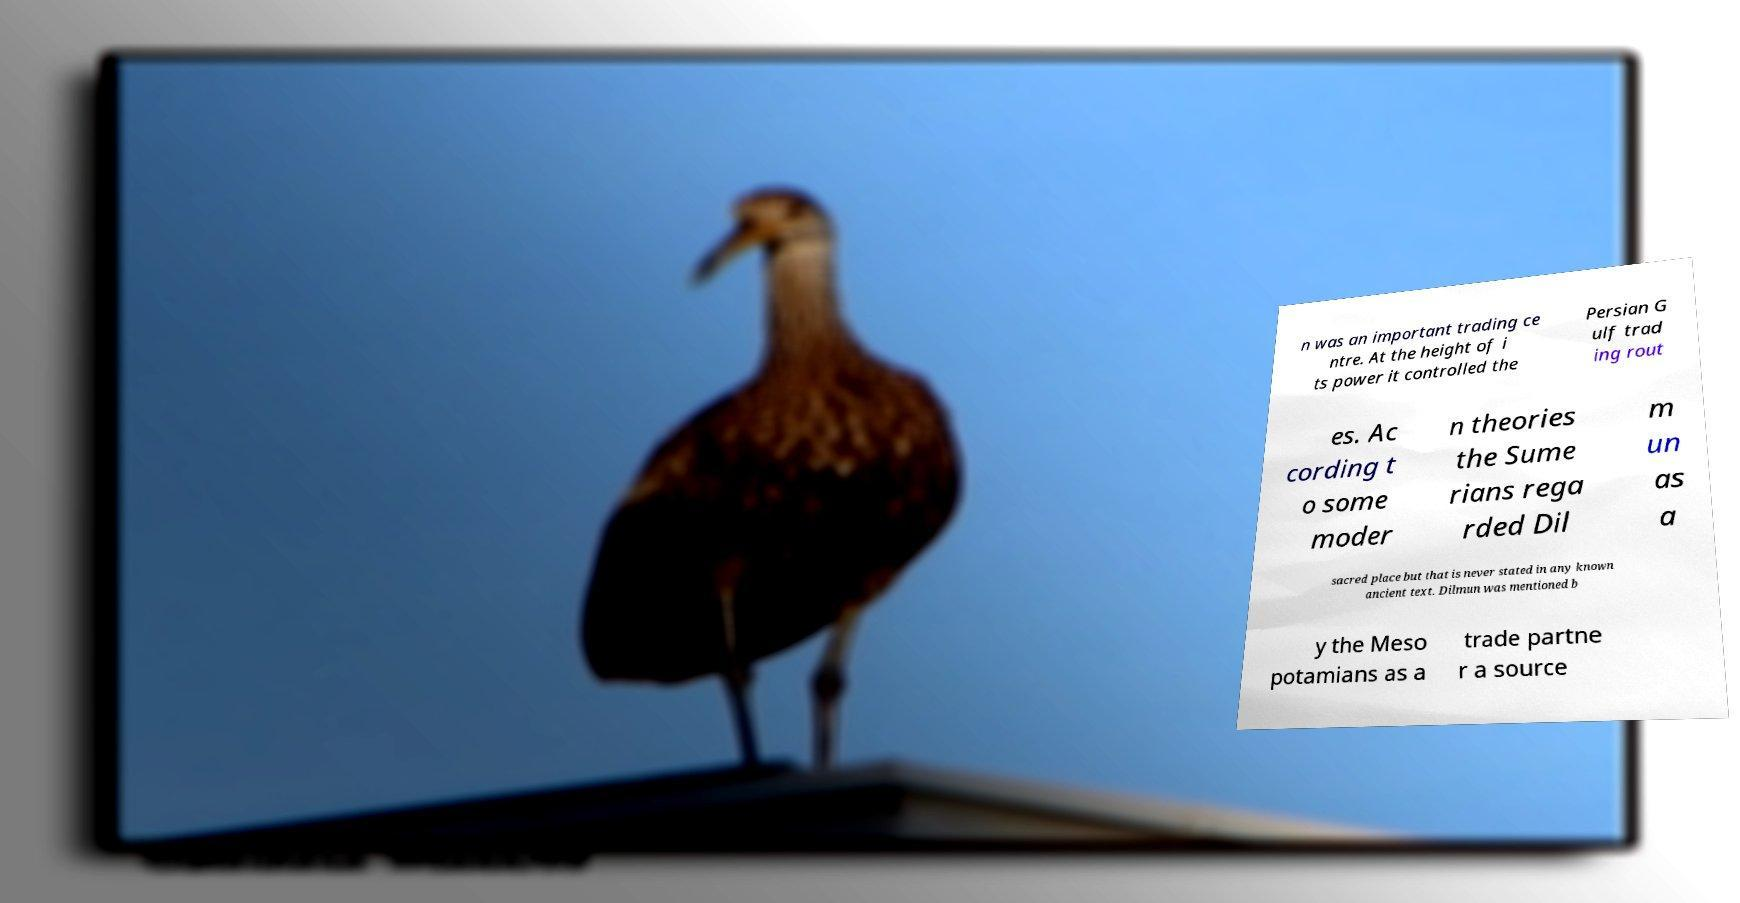Can you read and provide the text displayed in the image?This photo seems to have some interesting text. Can you extract and type it out for me? n was an important trading ce ntre. At the height of i ts power it controlled the Persian G ulf trad ing rout es. Ac cording t o some moder n theories the Sume rians rega rded Dil m un as a sacred place but that is never stated in any known ancient text. Dilmun was mentioned b y the Meso potamians as a trade partne r a source 